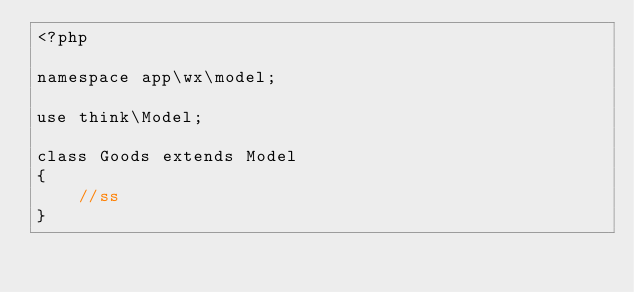Convert code to text. <code><loc_0><loc_0><loc_500><loc_500><_PHP_><?php

namespace app\wx\model;

use think\Model;

class Goods extends Model
{
    //ss
}
</code> 